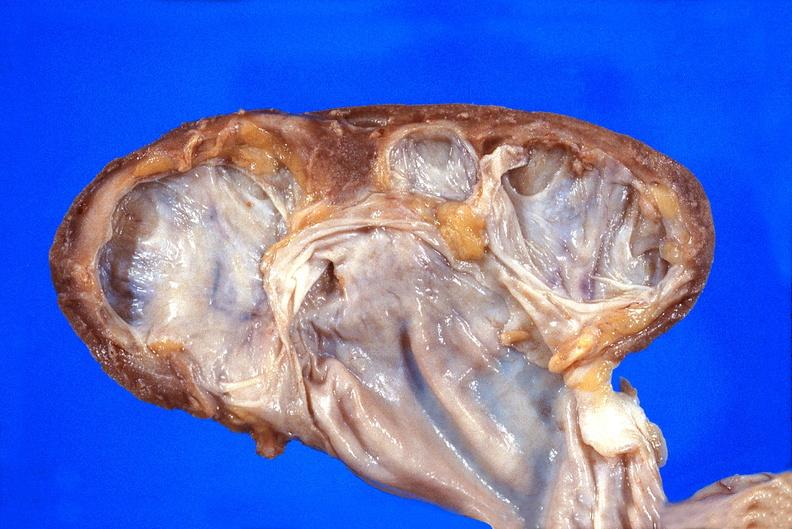where is this?
Answer the question using a single word or phrase. Urinary 